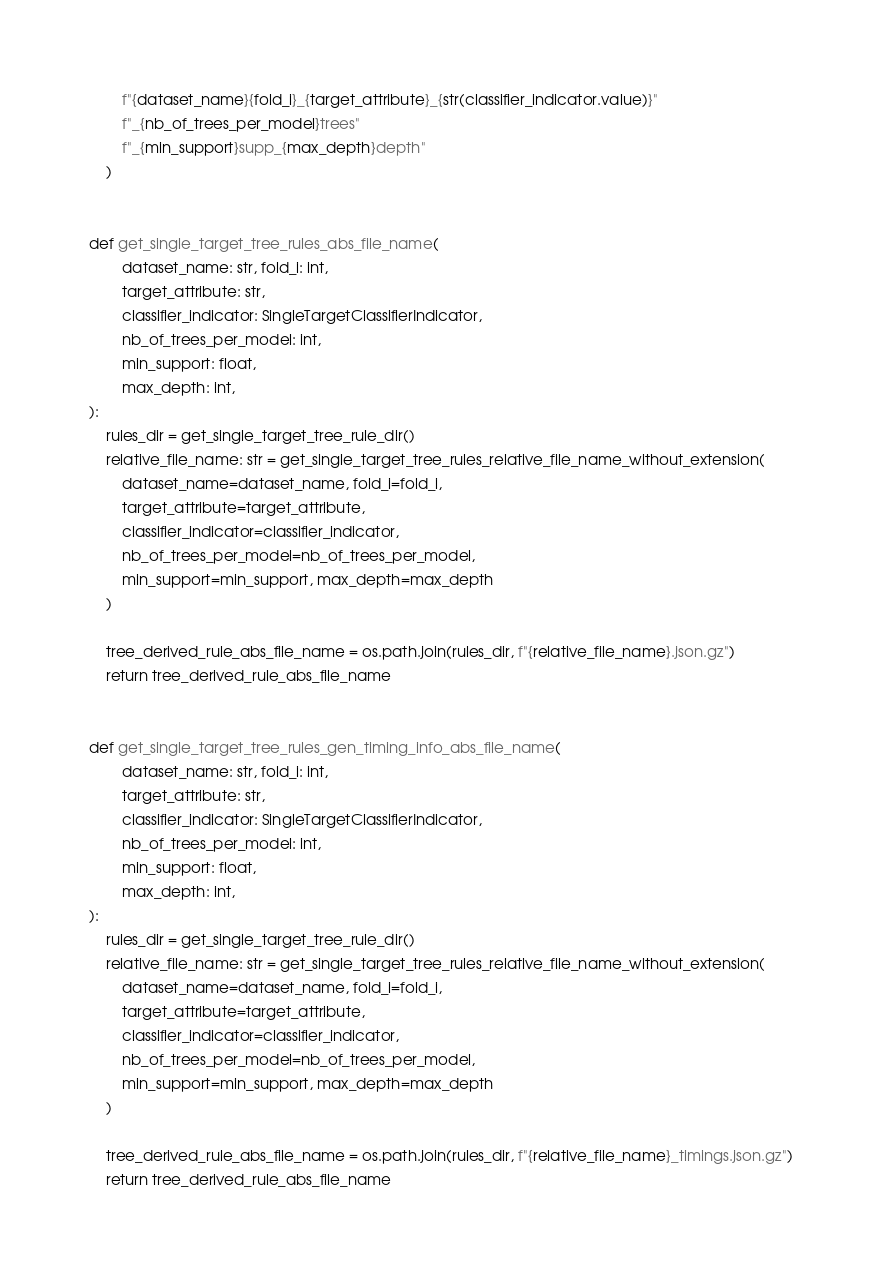Convert code to text. <code><loc_0><loc_0><loc_500><loc_500><_Python_>        f"{dataset_name}{fold_i}_{target_attribute}_{str(classifier_indicator.value)}"
        f"_{nb_of_trees_per_model}trees"
        f"_{min_support}supp_{max_depth}depth"
    )


def get_single_target_tree_rules_abs_file_name(
        dataset_name: str, fold_i: int,
        target_attribute: str,
        classifier_indicator: SingleTargetClassifierIndicator,
        nb_of_trees_per_model: int,
        min_support: float,
        max_depth: int,
):
    rules_dir = get_single_target_tree_rule_dir()
    relative_file_name: str = get_single_target_tree_rules_relative_file_name_without_extension(
        dataset_name=dataset_name, fold_i=fold_i,
        target_attribute=target_attribute,
        classifier_indicator=classifier_indicator,
        nb_of_trees_per_model=nb_of_trees_per_model,
        min_support=min_support, max_depth=max_depth
    )

    tree_derived_rule_abs_file_name = os.path.join(rules_dir, f"{relative_file_name}.json.gz")
    return tree_derived_rule_abs_file_name


def get_single_target_tree_rules_gen_timing_info_abs_file_name(
        dataset_name: str, fold_i: int,
        target_attribute: str,
        classifier_indicator: SingleTargetClassifierIndicator,
        nb_of_trees_per_model: int,
        min_support: float,
        max_depth: int,
):
    rules_dir = get_single_target_tree_rule_dir()
    relative_file_name: str = get_single_target_tree_rules_relative_file_name_without_extension(
        dataset_name=dataset_name, fold_i=fold_i,
        target_attribute=target_attribute,
        classifier_indicator=classifier_indicator,
        nb_of_trees_per_model=nb_of_trees_per_model,
        min_support=min_support, max_depth=max_depth
    )

    tree_derived_rule_abs_file_name = os.path.join(rules_dir, f"{relative_file_name}_timings.json.gz")
    return tree_derived_rule_abs_file_name
</code> 